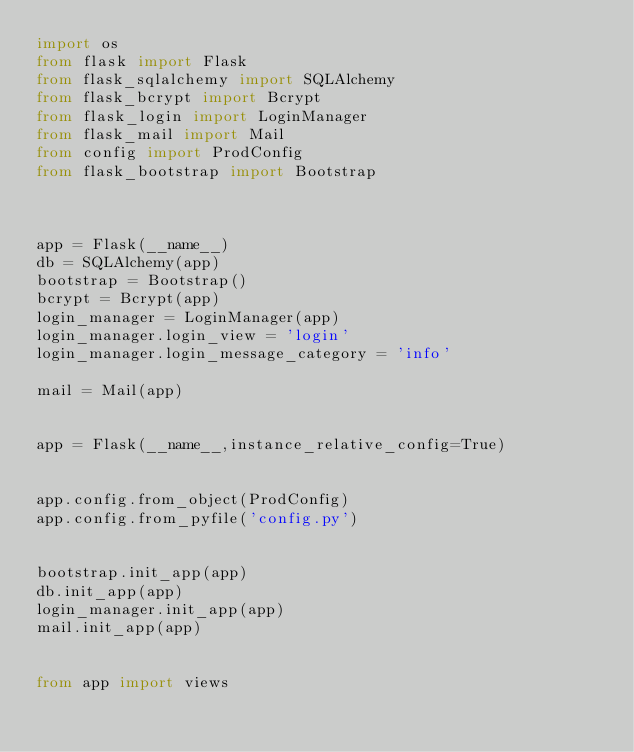<code> <loc_0><loc_0><loc_500><loc_500><_Python_>import os
from flask import Flask
from flask_sqlalchemy import SQLAlchemy
from flask_bcrypt import Bcrypt
from flask_login import LoginManager
from flask_mail import Mail
from config import ProdConfig
from flask_bootstrap import Bootstrap



app = Flask(__name__)
db = SQLAlchemy(app)
bootstrap = Bootstrap()
bcrypt = Bcrypt(app)
login_manager = LoginManager(app)
login_manager.login_view = 'login'
login_manager.login_message_category = 'info'

mail = Mail(app)


app = Flask(__name__,instance_relative_config=True)


app.config.from_object(ProdConfig)
app.config.from_pyfile('config.py')


bootstrap.init_app(app)
db.init_app(app)
login_manager.init_app(app)
mail.init_app(app)


from app import views</code> 